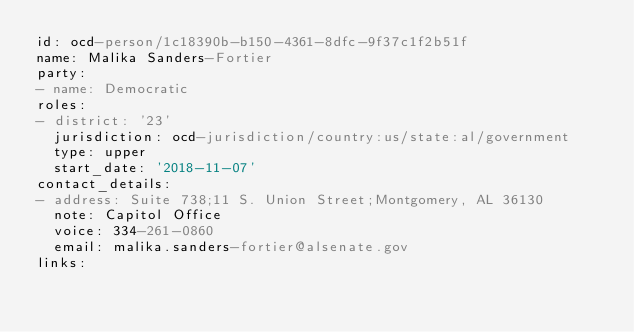<code> <loc_0><loc_0><loc_500><loc_500><_YAML_>id: ocd-person/1c18390b-b150-4361-8dfc-9f37c1f2b51f
name: Malika Sanders-Fortier
party:
- name: Democratic
roles:
- district: '23'
  jurisdiction: ocd-jurisdiction/country:us/state:al/government
  type: upper
  start_date: '2018-11-07'
contact_details:
- address: Suite 738;11 S. Union Street;Montgomery, AL 36130
  note: Capitol Office
  voice: 334-261-0860
  email: malika.sanders-fortier@alsenate.gov
links:</code> 